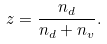<formula> <loc_0><loc_0><loc_500><loc_500>z = \frac { n _ { d } } { n _ { d } + n _ { v } } .</formula> 